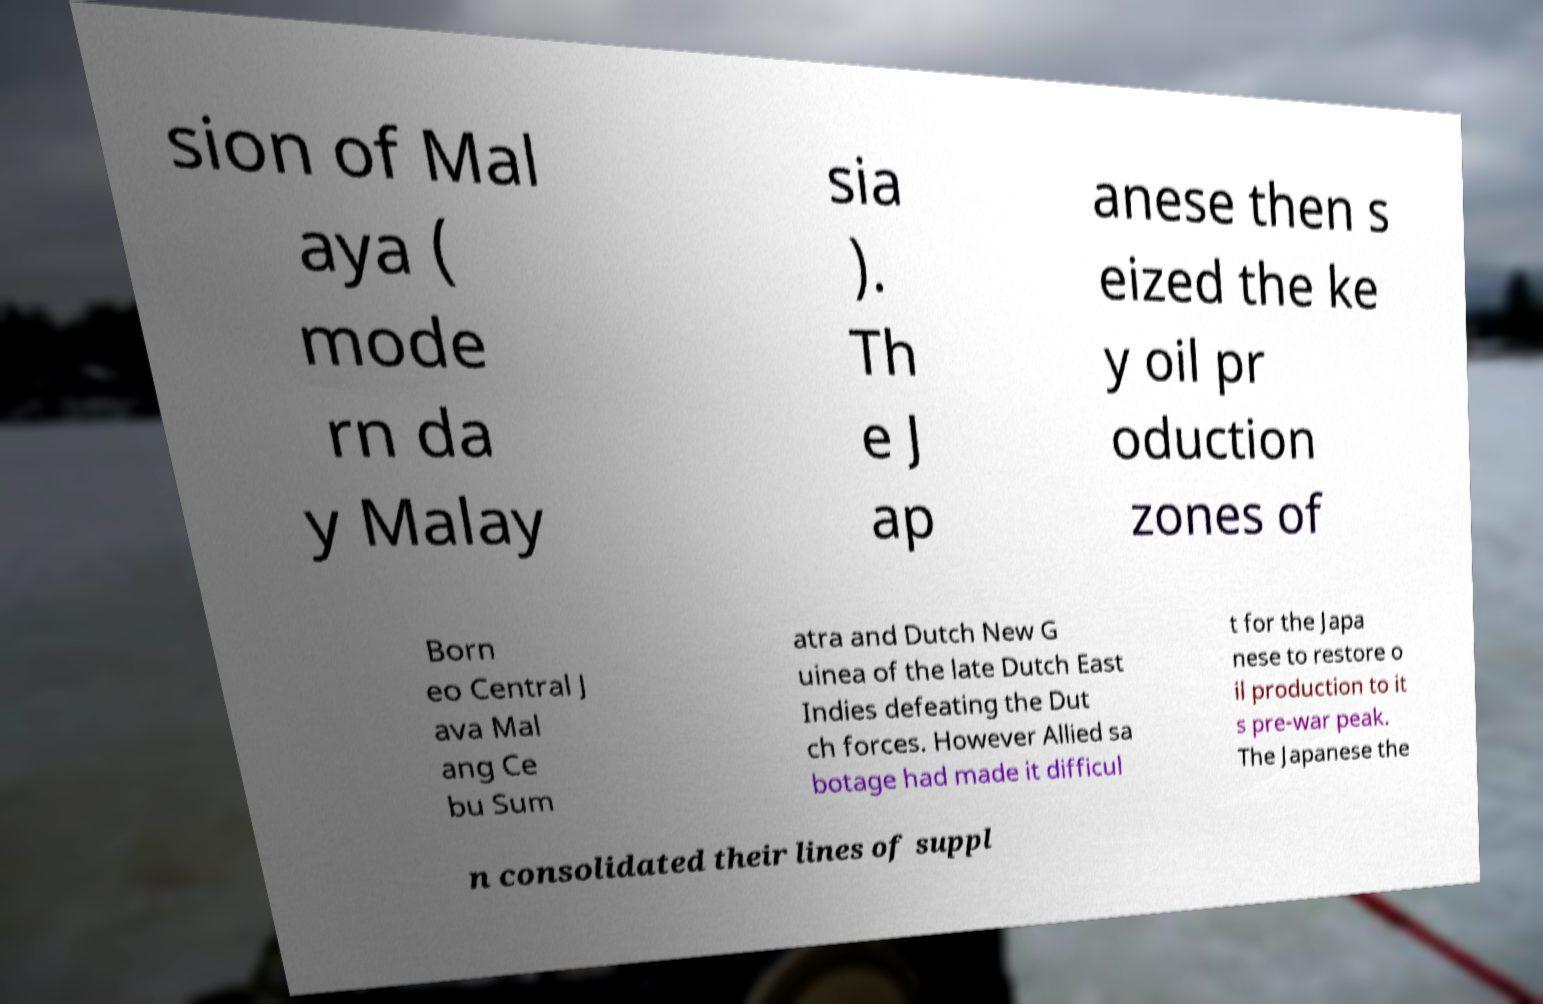Please identify and transcribe the text found in this image. sion of Mal aya ( mode rn da y Malay sia ). Th e J ap anese then s eized the ke y oil pr oduction zones of Born eo Central J ava Mal ang Ce bu Sum atra and Dutch New G uinea of the late Dutch East Indies defeating the Dut ch forces. However Allied sa botage had made it difficul t for the Japa nese to restore o il production to it s pre-war peak. The Japanese the n consolidated their lines of suppl 